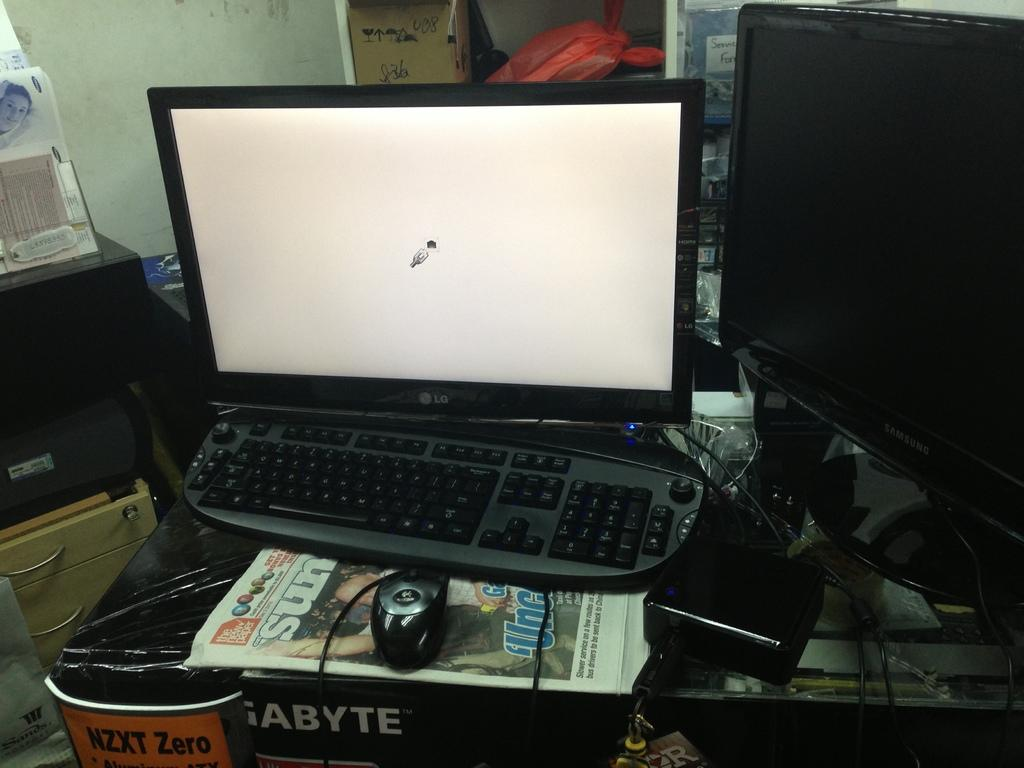<image>
Render a clear and concise summary of the photo. An LG laptop computer sits on a black desk. 